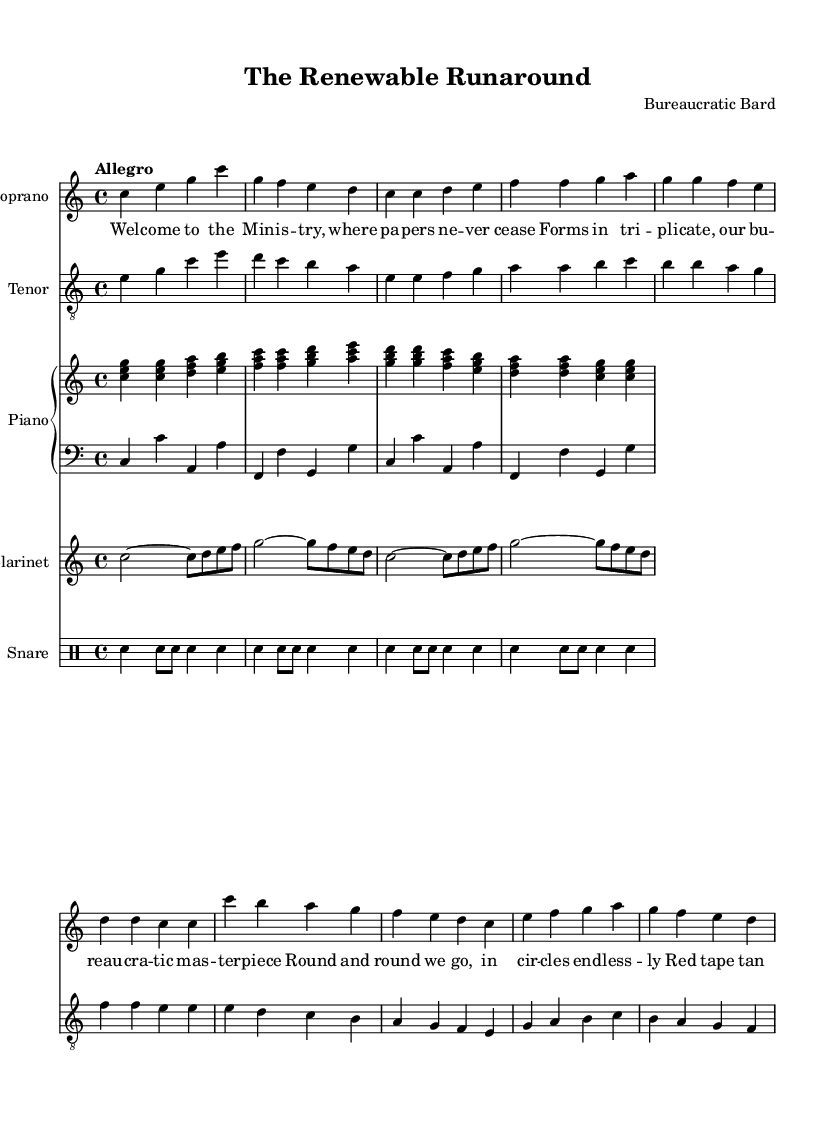What is the key signature of this music? The key signature is found at the beginning of the staff, where there are no sharps or flats, indicating the key is C major.
Answer: C major What is the time signature of this piece? The time signature is indicated at the beginning of the score, which shows 4/4, meaning there are four beats per measure and a quarter note receives one beat.
Answer: 4/4 What tempo marking is indicated? The tempo marking is found at the beginning of the score, reading "Allegro," indicating a fast tempo, typically around 120–168 beats per minute.
Answer: Allegro How many staves are used for the piano part? The piano part is presented as a PianoStaff which consists of two staves, one for the treble and one for the bass clef, indicating the standard layout for piano music.
Answer: Two Which instruments are included in this score? By reviewing the score, we can see various staves are labeled clearly as Soprano, Tenor, Piano, Clarinet, and Snare, indicating the instrumentation included.
Answer: Soprano, Tenor, Piano, Clarinet, Snare What is the refrain from the lyrics describing? The lyrics suggest a focus on bureaucracy and red tape, indicating the theme of the comedic opera satirizing government processes, particularly in energy departments.
Answer: Bureaucracy 